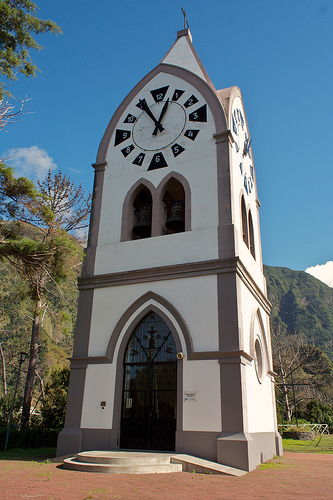What stories could this clock tower tell? This clock tower could tell stories of the past, perhaps being witness to the growth of the town around it. It could share the tales of people who’ve gathered beneath it across generations, marking significant moments or watching as seasons change. The bell might have tolled for celebrations, warnings, and the passage of time, resonating with the memories of the community. Provide a detailed history of this clock tower. The clock tower, constructed in the late 19th century, was built by local craftsmen using stone from the nearby hills. Initially serving as both a timekeeper and a community meeting spot, it played a key role in daily life. Through years of historical events, such as the turn of the century, wartime efforts, and urban development, it remained a symbol of resilience and continuity. The tower underwent several renovations, each adding to its architectural charm, and now stands as a testament to the area's rich heritage. The bell, cast in a renowned foundry, rings with a tone that has become synonymous with the town's identity. If the tower could move, where would it travel first? If the tower could miraculously set itself in motion, perhaps it would first travel to the town's central square to be closer to the heart of the community during festivals. It might then journey to the tallest hill to oversee the entirety of its domain, ensuring everyone could see its timekeeping face. For a dream escapade, it could venture to distant lands, exchanging cultural tales with other historical landmarks, becoming an ambassador of its town's legacy. Describe a realistic scenario where someone uses the clock tower as a meeting point. In a realistic scenario, two friends might decide to meet at the clock tower on a sunny afternoon for a leisurely walk around the town. One friend might arrive early, taking the time to admire the intricate craftsmanship of the tower and the serene surroundings, while the other arrives right on time, guided by the prominent clock face visible from a distance. Can you provide a short narrative involving the clock tower? As the afternoon sun reached its peak, the clock tower stood tall, casting a shadow on the ground below. A couple, hand in hand, approached the tower to take a photo, capturing the memories of their visit. The bell rang out, marking the hour, and they smiled, knowing that they would remember this moment for years to come. 